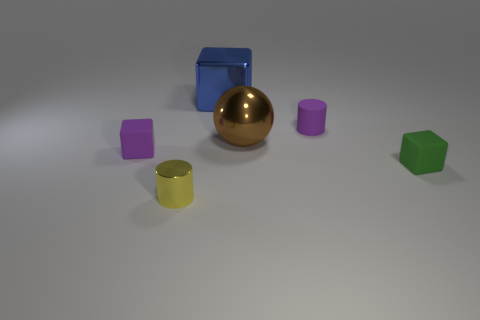There is a tiny rubber object to the right of the small purple matte object that is right of the purple object in front of the large ball; what color is it?
Provide a succinct answer. Green. Is the number of purple blocks in front of the big brown object greater than the number of large metallic objects that are behind the tiny green rubber thing?
Keep it short and to the point. No. What number of other objects are there of the same size as the brown sphere?
Your response must be concise. 1. There is a matte thing that is the same color as the matte cylinder; what size is it?
Keep it short and to the point. Small. The block that is behind the rubber cube that is left of the green object is made of what material?
Make the answer very short. Metal. Are there any matte cubes to the right of the matte cylinder?
Your answer should be compact. Yes. Is the number of purple matte cylinders that are behind the tiny green cube greater than the number of large cyan cylinders?
Your answer should be very brief. Yes. Is there a tiny cube that has the same color as the tiny rubber cylinder?
Provide a succinct answer. Yes. What color is the cylinder that is the same size as the yellow thing?
Give a very brief answer. Purple. There is a small purple object to the left of the tiny purple matte cylinder; is there a tiny cube in front of it?
Your answer should be very brief. Yes. 